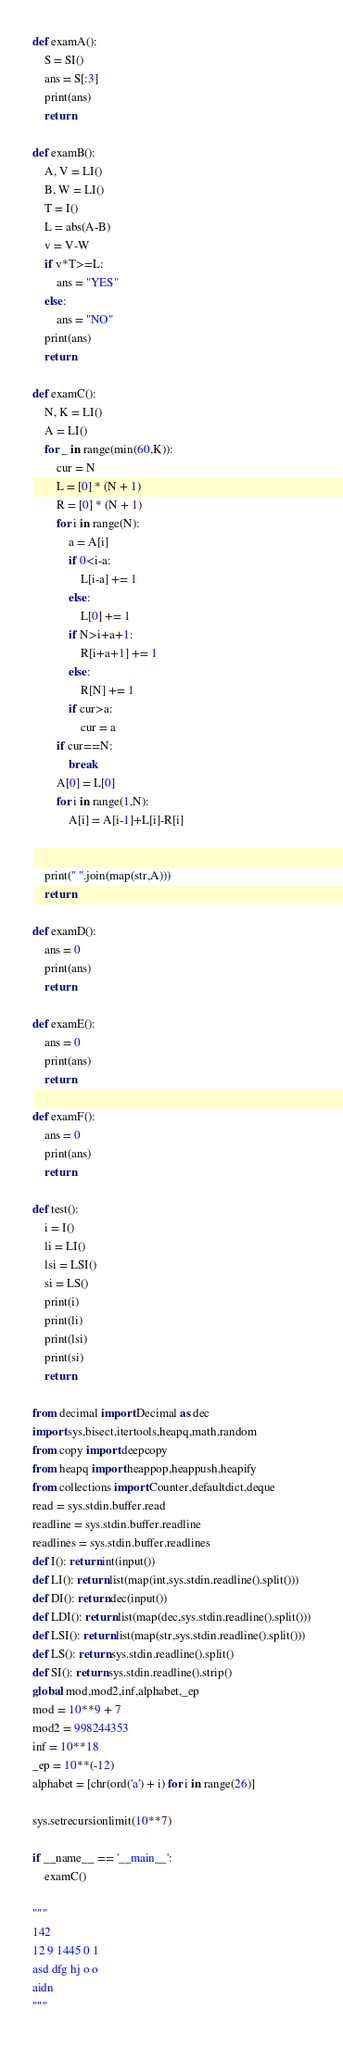Convert code to text. <code><loc_0><loc_0><loc_500><loc_500><_Python_>def examA():
    S = SI()
    ans = S[:3]
    print(ans)
    return

def examB():
    A, V = LI()
    B, W = LI()
    T = I()
    L = abs(A-B)
    v = V-W
    if v*T>=L:
        ans = "YES"
    else:
        ans = "NO"
    print(ans)
    return

def examC():
    N, K = LI()
    A = LI()
    for _ in range(min(60,K)):
        cur = N
        L = [0] * (N + 1)
        R = [0] * (N + 1)
        for i in range(N):
            a = A[i]
            if 0<i-a:
                L[i-a] += 1
            else:
                L[0] += 1
            if N>i+a+1:
                R[i+a+1] += 1
            else:
                R[N] += 1
            if cur>a:
                cur = a
        if cur==N:
            break
        A[0] = L[0]
        for i in range(1,N):
            A[i] = A[i-1]+L[i]-R[i]


    print(" ".join(map(str,A)))
    return

def examD():
    ans = 0
    print(ans)
    return

def examE():
    ans = 0
    print(ans)
    return

def examF():
    ans = 0
    print(ans)
    return

def test():
    i = I()
    li = LI()
    lsi = LSI()
    si = LS()
    print(i)
    print(li)
    print(lsi)
    print(si)
    return

from decimal import Decimal as dec
import sys,bisect,itertools,heapq,math,random
from copy import deepcopy
from heapq import heappop,heappush,heapify
from collections import Counter,defaultdict,deque
read = sys.stdin.buffer.read
readline = sys.stdin.buffer.readline
readlines = sys.stdin.buffer.readlines
def I(): return int(input())
def LI(): return list(map(int,sys.stdin.readline().split()))
def DI(): return dec(input())
def LDI(): return list(map(dec,sys.stdin.readline().split()))
def LSI(): return list(map(str,sys.stdin.readline().split()))
def LS(): return sys.stdin.readline().split()
def SI(): return sys.stdin.readline().strip()
global mod,mod2,inf,alphabet,_ep
mod = 10**9 + 7
mod2 = 998244353
inf = 10**18
_ep = 10**(-12)
alphabet = [chr(ord('a') + i) for i in range(26)]

sys.setrecursionlimit(10**7)

if __name__ == '__main__':
    examC()

"""
142
12 9 1445 0 1
asd dfg hj o o
aidn
"""</code> 